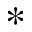<formula> <loc_0><loc_0><loc_500><loc_500>*</formula> 